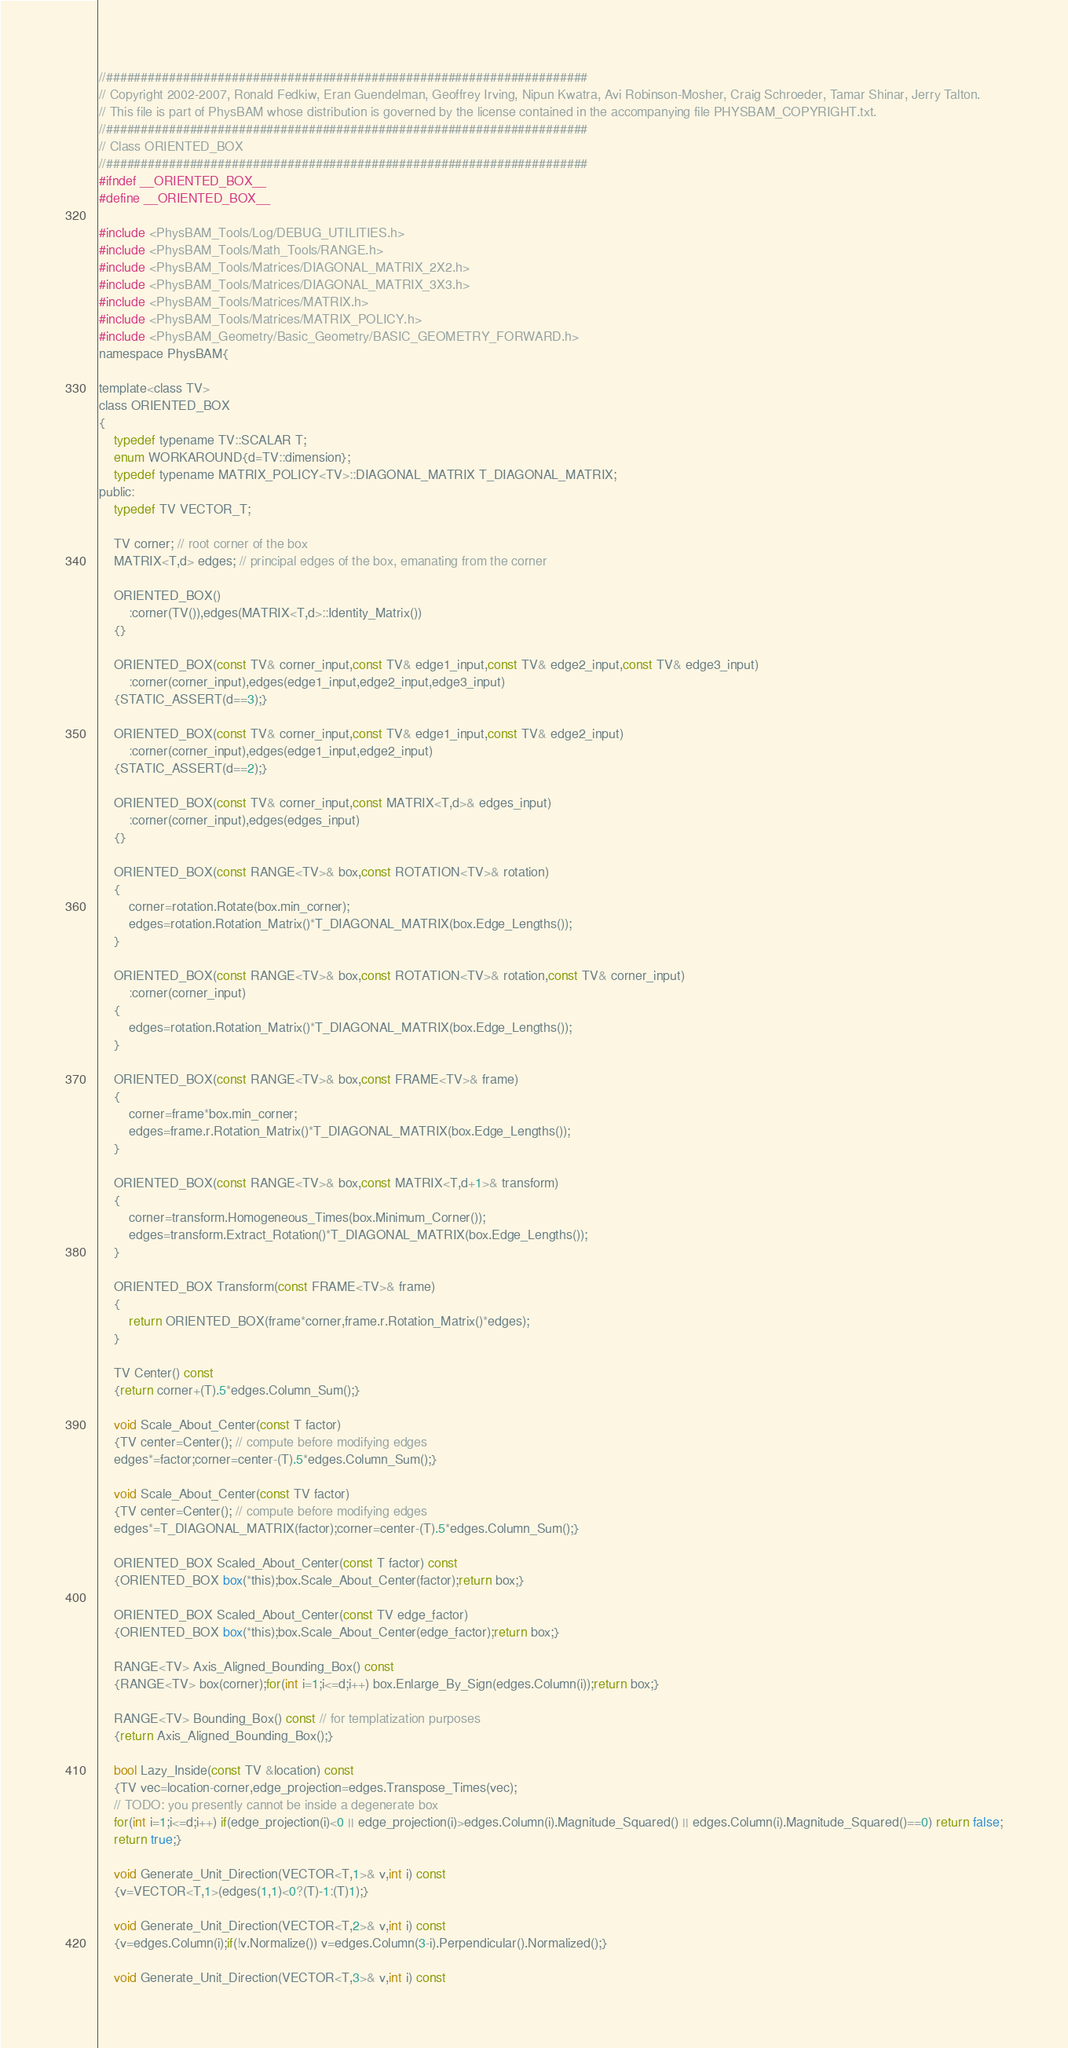<code> <loc_0><loc_0><loc_500><loc_500><_C_>//#####################################################################
// Copyright 2002-2007, Ronald Fedkiw, Eran Guendelman, Geoffrey Irving, Nipun Kwatra, Avi Robinson-Mosher, Craig Schroeder, Tamar Shinar, Jerry Talton.
// This file is part of PhysBAM whose distribution is governed by the license contained in the accompanying file PHYSBAM_COPYRIGHT.txt.
//#####################################################################
// Class ORIENTED_BOX
//#####################################################################
#ifndef __ORIENTED_BOX__
#define __ORIENTED_BOX__

#include <PhysBAM_Tools/Log/DEBUG_UTILITIES.h>
#include <PhysBAM_Tools/Math_Tools/RANGE.h>
#include <PhysBAM_Tools/Matrices/DIAGONAL_MATRIX_2X2.h>
#include <PhysBAM_Tools/Matrices/DIAGONAL_MATRIX_3X3.h>
#include <PhysBAM_Tools/Matrices/MATRIX.h>
#include <PhysBAM_Tools/Matrices/MATRIX_POLICY.h>
#include <PhysBAM_Geometry/Basic_Geometry/BASIC_GEOMETRY_FORWARD.h>
namespace PhysBAM{

template<class TV>
class ORIENTED_BOX
{
    typedef typename TV::SCALAR T;
    enum WORKAROUND{d=TV::dimension};
    typedef typename MATRIX_POLICY<TV>::DIAGONAL_MATRIX T_DIAGONAL_MATRIX;
public:
    typedef TV VECTOR_T;

    TV corner; // root corner of the box
    MATRIX<T,d> edges; // principal edges of the box, emanating from the corner

    ORIENTED_BOX()
        :corner(TV()),edges(MATRIX<T,d>::Identity_Matrix())
    {}

    ORIENTED_BOX(const TV& corner_input,const TV& edge1_input,const TV& edge2_input,const TV& edge3_input)
        :corner(corner_input),edges(edge1_input,edge2_input,edge3_input)
    {STATIC_ASSERT(d==3);}

    ORIENTED_BOX(const TV& corner_input,const TV& edge1_input,const TV& edge2_input)
        :corner(corner_input),edges(edge1_input,edge2_input)
    {STATIC_ASSERT(d==2);}

    ORIENTED_BOX(const TV& corner_input,const MATRIX<T,d>& edges_input)
        :corner(corner_input),edges(edges_input)
    {}

    ORIENTED_BOX(const RANGE<TV>& box,const ROTATION<TV>& rotation)
    {
        corner=rotation.Rotate(box.min_corner);
        edges=rotation.Rotation_Matrix()*T_DIAGONAL_MATRIX(box.Edge_Lengths());
    }

    ORIENTED_BOX(const RANGE<TV>& box,const ROTATION<TV>& rotation,const TV& corner_input)
        :corner(corner_input)
    {
        edges=rotation.Rotation_Matrix()*T_DIAGONAL_MATRIX(box.Edge_Lengths());
    }

    ORIENTED_BOX(const RANGE<TV>& box,const FRAME<TV>& frame)
    {
        corner=frame*box.min_corner;
        edges=frame.r.Rotation_Matrix()*T_DIAGONAL_MATRIX(box.Edge_Lengths());
    }

    ORIENTED_BOX(const RANGE<TV>& box,const MATRIX<T,d+1>& transform)
    {
        corner=transform.Homogeneous_Times(box.Minimum_Corner());
        edges=transform.Extract_Rotation()*T_DIAGONAL_MATRIX(box.Edge_Lengths());
    }

    ORIENTED_BOX Transform(const FRAME<TV>& frame)
    {
        return ORIENTED_BOX(frame*corner,frame.r.Rotation_Matrix()*edges);
    }

    TV Center() const
    {return corner+(T).5*edges.Column_Sum();}

    void Scale_About_Center(const T factor)
    {TV center=Center(); // compute before modifying edges
    edges*=factor;corner=center-(T).5*edges.Column_Sum();}

    void Scale_About_Center(const TV factor)
    {TV center=Center(); // compute before modifying edges
    edges*=T_DIAGONAL_MATRIX(factor);corner=center-(T).5*edges.Column_Sum();}

    ORIENTED_BOX Scaled_About_Center(const T factor) const
    {ORIENTED_BOX box(*this);box.Scale_About_Center(factor);return box;}

    ORIENTED_BOX Scaled_About_Center(const TV edge_factor)
    {ORIENTED_BOX box(*this);box.Scale_About_Center(edge_factor);return box;}

    RANGE<TV> Axis_Aligned_Bounding_Box() const
    {RANGE<TV> box(corner);for(int i=1;i<=d;i++) box.Enlarge_By_Sign(edges.Column(i));return box;}

    RANGE<TV> Bounding_Box() const // for templatization purposes
    {return Axis_Aligned_Bounding_Box();}

    bool Lazy_Inside(const TV &location) const
    {TV vec=location-corner,edge_projection=edges.Transpose_Times(vec);
    // TODO: you presently cannot be inside a degenerate box
    for(int i=1;i<=d;i++) if(edge_projection(i)<0 || edge_projection(i)>edges.Column(i).Magnitude_Squared() || edges.Column(i).Magnitude_Squared()==0) return false;
    return true;}

    void Generate_Unit_Direction(VECTOR<T,1>& v,int i) const
    {v=VECTOR<T,1>(edges(1,1)<0?(T)-1:(T)1);}

    void Generate_Unit_Direction(VECTOR<T,2>& v,int i) const
    {v=edges.Column(i);if(!v.Normalize()) v=edges.Column(3-i).Perpendicular().Normalized();}

    void Generate_Unit_Direction(VECTOR<T,3>& v,int i) const</code> 